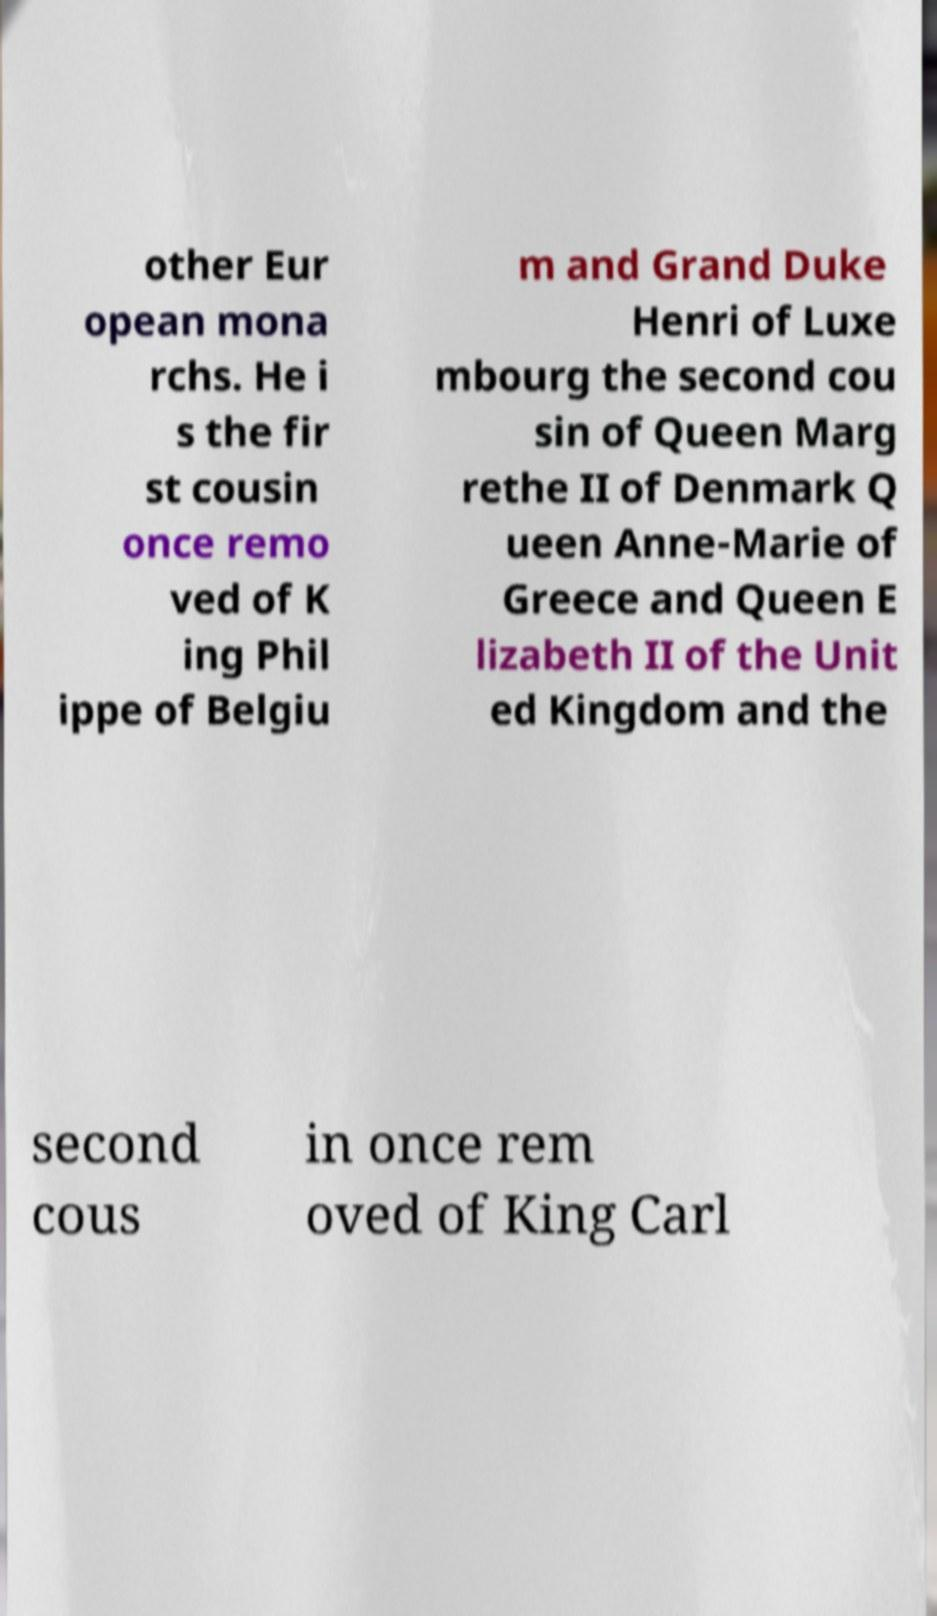Please identify and transcribe the text found in this image. other Eur opean mona rchs. He i s the fir st cousin once remo ved of K ing Phil ippe of Belgiu m and Grand Duke Henri of Luxe mbourg the second cou sin of Queen Marg rethe II of Denmark Q ueen Anne-Marie of Greece and Queen E lizabeth II of the Unit ed Kingdom and the second cous in once rem oved of King Carl 